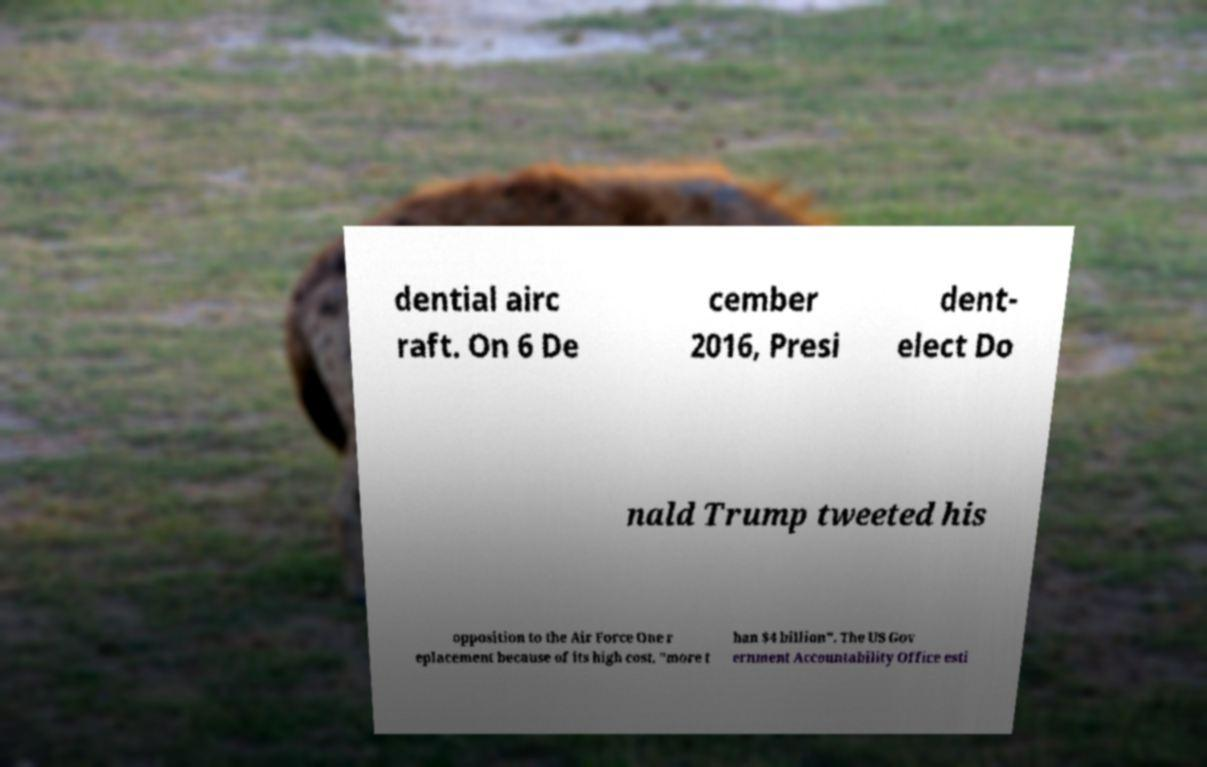There's text embedded in this image that I need extracted. Can you transcribe it verbatim? dential airc raft. On 6 De cember 2016, Presi dent- elect Do nald Trump tweeted his opposition to the Air Force One r eplacement because of its high cost, "more t han $4 billion". The US Gov ernment Accountability Office esti 